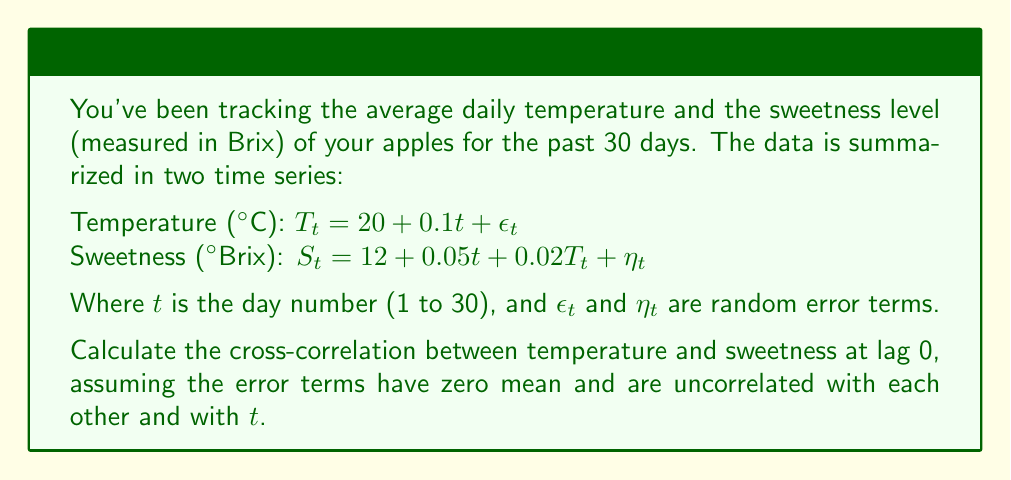Show me your answer to this math problem. To calculate the cross-correlation between temperature and sweetness at lag 0, we need to follow these steps:

1) First, let's recall the formula for cross-correlation at lag 0:

   $$\rho_{TS}(0) = \frac{Cov(T_t, S_t)}{\sqrt{Var(T_t) \cdot Var(S_t)}}$$

2) We need to calculate $Cov(T_t, S_t)$, $Var(T_t)$, and $Var(S_t)$.

3) For $T_t$:
   $E[T_t] = 20 + 0.1t$
   $Var(T_t) = Var(\epsilon_t)$ (let's call this $\sigma_\epsilon^2$)

4) For $S_t$:
   $E[S_t] = 12 + 0.05t + 0.02E[T_t] = 12 + 0.05t + 0.02(20 + 0.1t) = 12.4 + 0.052t$
   $Var(S_t) = (0.02)^2Var(T_t) + Var(\eta_t) = 0.0004\sigma_\epsilon^2 + \sigma_\eta^2$

5) Now for $Cov(T_t, S_t)$:
   $Cov(T_t, S_t) = Cov(20 + 0.1t + \epsilon_t, 12 + 0.05t + 0.02T_t + \eta_t)$
   $= Cov(20 + 0.1t + \epsilon_t, 12 + 0.05t + 0.02(20 + 0.1t + \epsilon_t) + \eta_t)$
   $= Cov(\epsilon_t, 0.02\epsilon_t) = 0.02Var(\epsilon_t) = 0.02\sigma_\epsilon^2$

6) Putting it all together:

   $$\rho_{TS}(0) = \frac{0.02\sigma_\epsilon^2}{\sqrt{\sigma_\epsilon^2 \cdot (0.0004\sigma_\epsilon^2 + \sigma_\eta^2)}}$$

7) Simplifying:

   $$\rho_{TS}(0) = \frac{0.02}{\sqrt{0.0004 + \sigma_\eta^2/\sigma_\epsilon^2}}$$

This is the final expression for the cross-correlation at lag 0.
Answer: $$\rho_{TS}(0) = \frac{0.02}{\sqrt{0.0004 + \sigma_\eta^2/\sigma_\epsilon^2}}$$ 